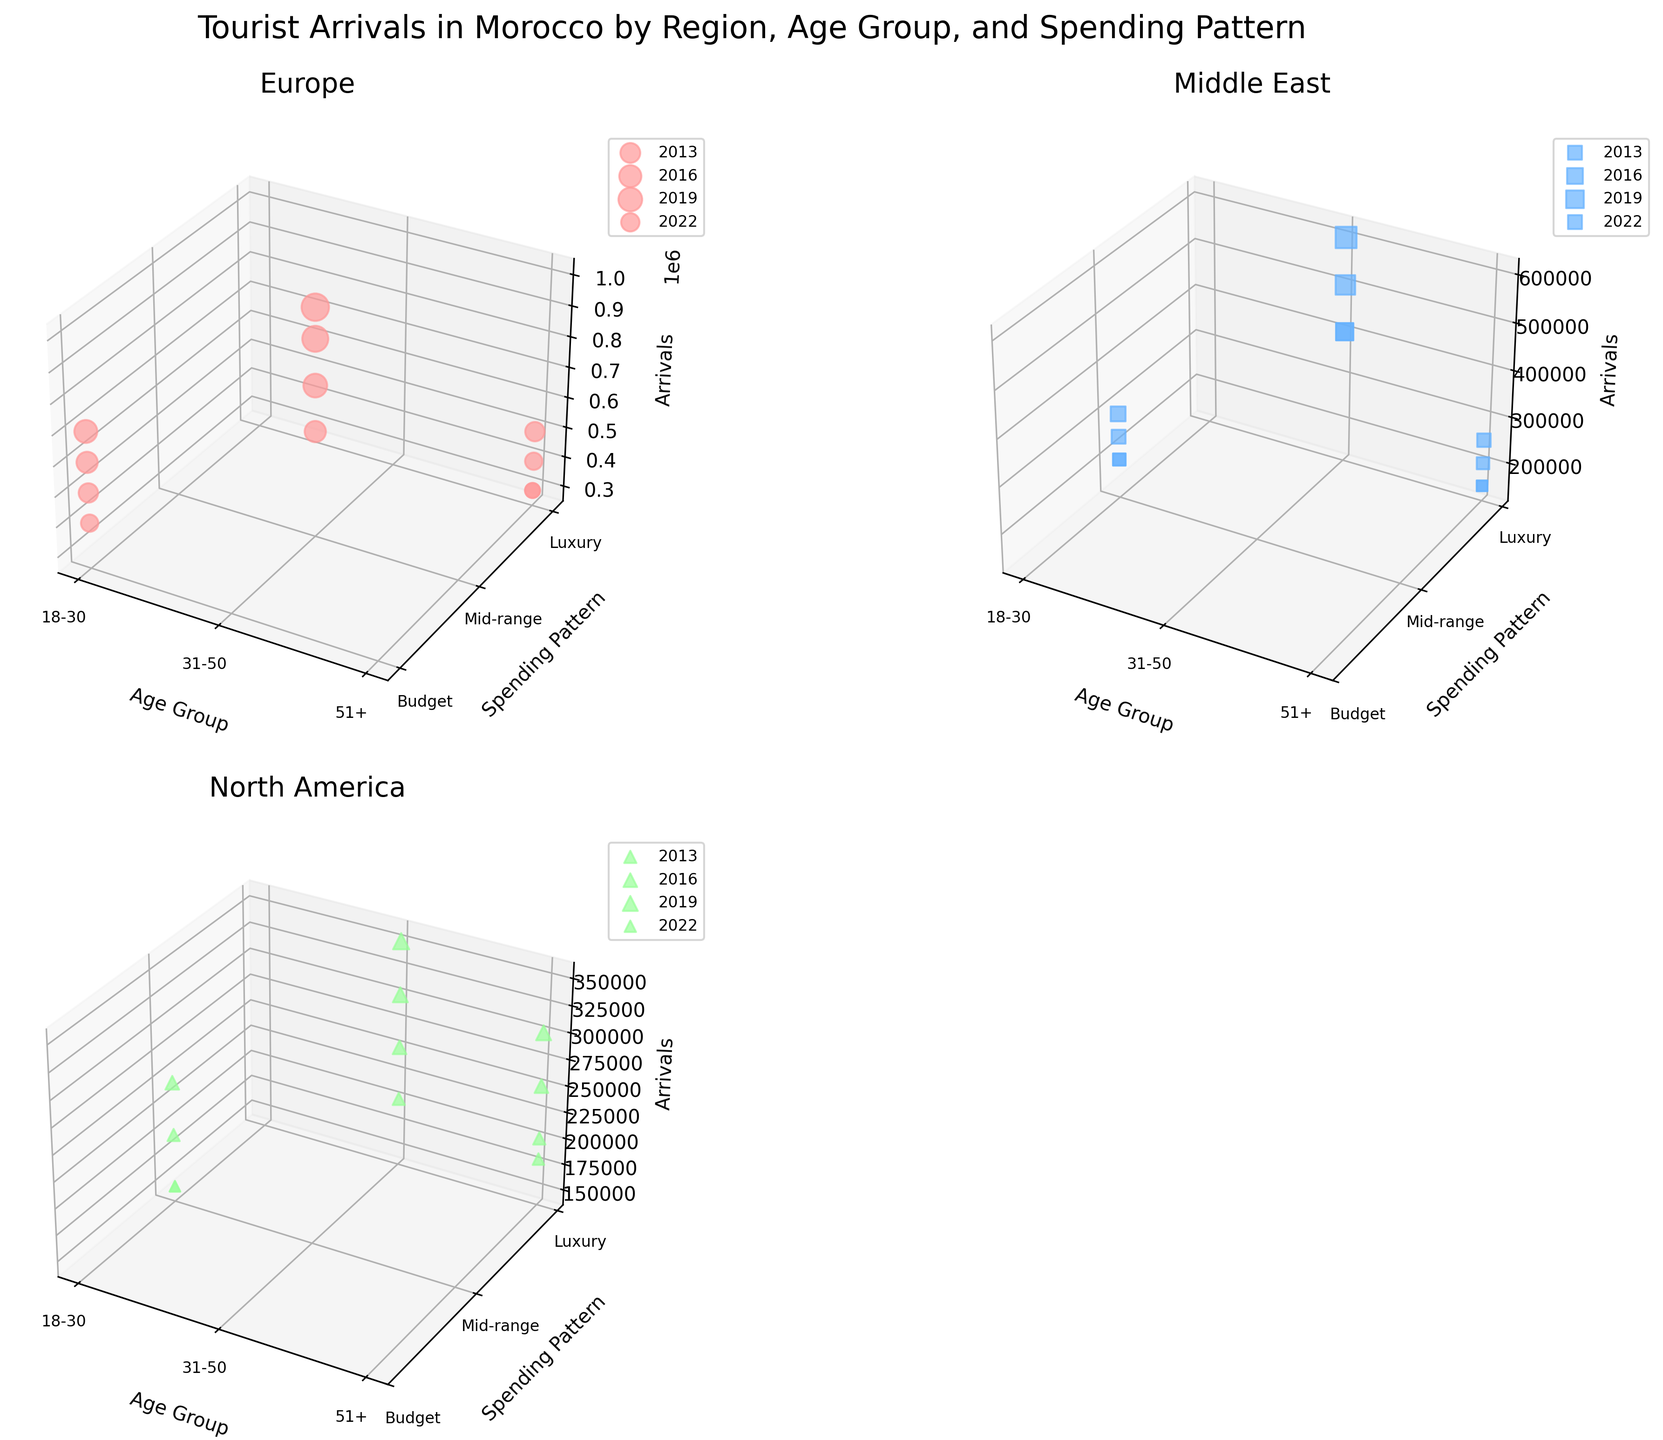What are the axes labels for the Europe region plot? The Europe region plot's axes are labeled as 'Age Group' on the x-axis, 'Spending Pattern' on the y-axis, and 'Arrivals' on the z-axis.
Answer: 'Age Group', 'Spending Pattern', 'Arrivals' Which region has the highest number of arrivals in 2019 for the age group 18-30 with a budget spending pattern? Look at each subplot for the year 2019, specifically at the '18-30' age group with 'Budget' spending. Europe in the subplot shows 700,000 arrivals, which is the highest.
Answer: Europe How did the number of arrivals for the age group 51+ from the Middle East with a luxury spending pattern change from 2013 to 2022? In 2013, the arrivals were 150,000. In 2022, the arrivals were also 150,000, indicating no change over this period.
Answer: No change Compare the number of arrivals for North Americans aged 31-50 with a luxury spending pattern between 2016 and 2019. In 2016, there were 300,000 arrivals for North Americans aged 31-50 with a luxury spending pattern, while in 2019 there were 350,000 arrivals, showing an increase.
Answer: Increased by 50,000 What is the trend in arrivals for Europeans aged 18-30 with a budget spending pattern from 2013 to 2022? In 2013, arrivals were 500,000; in 2016, it increased to 600,000; in 2019, it further increased to 700,000; but in 2022, it declined to 400,000. This indicates a rising trend until 2019 followed by a drop in 2022.
Answer: Rising until 2019, then dropped What was the overall spending pattern for North American tourists in 2019? By looking at the subplot for North America in 2019, it shows that the arrivals were highest for the luxury spending pattern, followed by mid-range for the age groups 18-30, 31-50, and 51+.
Answer: Luxury Which age group had the lowest number of arrivals from the Middle East in 2022? By examining the Middle East subplot for 2022, the 51+ age group with a luxury spending pattern had the lowest number of arrivals at 150,000.
Answer: 51+ In the Europe region, which age group had the highest number of arrivals with a mid-range spending pattern in 2016? For Europe in 2016, the 31-50 age group had the highest number of arrivals with a mid-range spending pattern, totaling 900,000.
Answer: 31-50 How did the number of arrivals for the Middle East region aged 18-30 with a mid-range spending pattern change from 2013 to 2019? In 2013, arrivals counted to 200,000, in 2016 it was 250,000, and in 2019 it increased to 300,000, showing a steady increase over the years.
Answer: Increased What is the total number of arrivals for Europeans across all age groups in 2022? European arrivals in 2022 were 400,000 (age 18-30) + 600,000 (age 31-50) + 300,000 (age 51+), totaling 1,300,000.
Answer: 1,300,000 